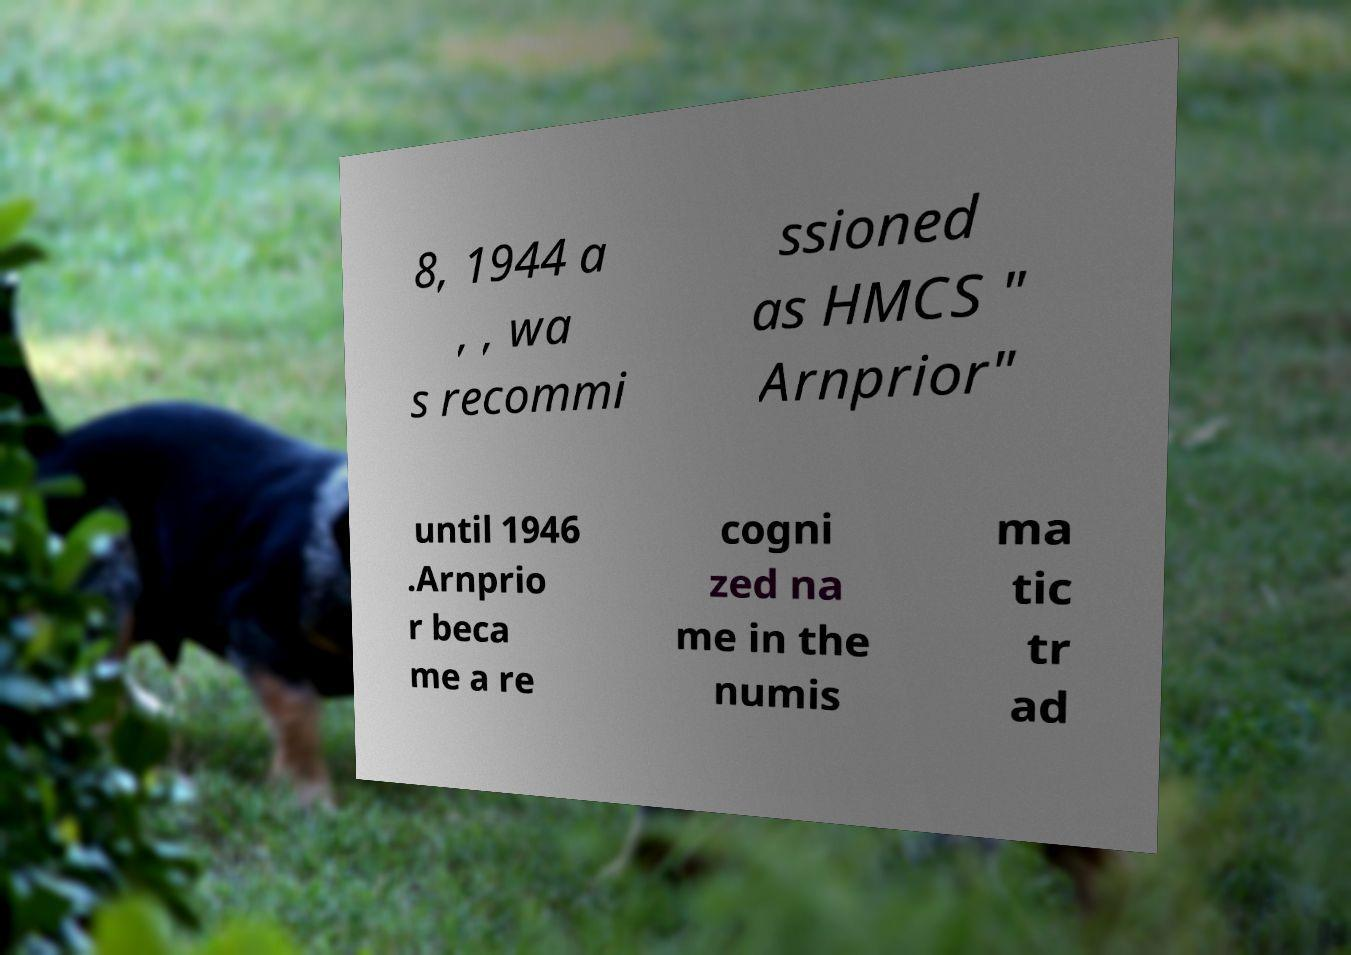There's text embedded in this image that I need extracted. Can you transcribe it verbatim? 8, 1944 a , , wa s recommi ssioned as HMCS " Arnprior" until 1946 .Arnprio r beca me a re cogni zed na me in the numis ma tic tr ad 